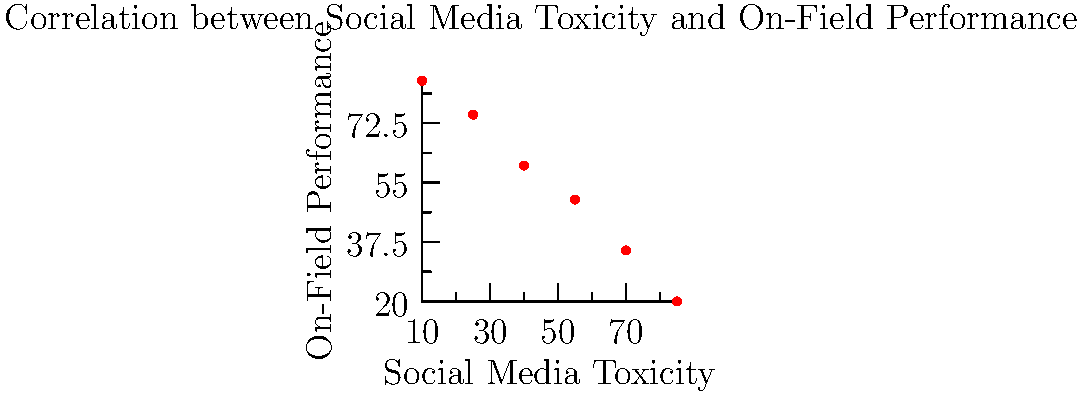Based on the scatter plot showing the relationship between social media toxicity and on-field performance for a soccer team, what type of correlation is observed, and how might this impact team morale? To answer this question, we need to analyze the scatter plot:

1. Observe the trend: As we move from left to right (increasing social media toxicity), the data points generally move downward (decreasing on-field performance).

2. Identify the correlation type: This pattern indicates a negative or inverse correlation between social media toxicity and on-field performance.

3. Strength of correlation: The points form a relatively straight line, suggesting a strong negative correlation.

4. Interpretation: As social media toxicity increases, on-field performance tends to decrease.

5. Impact on team morale:
   a) Players may feel discouraged by negative social media comments.
   b) Increased toxicity could lead to internal conflicts and reduced team cohesion.
   c) Constant criticism may affect players' confidence and mental well-being.
   d) The negative atmosphere could create a cycle of poor performance and increased toxicity.

6. Conclusion: The strong negative correlation suggests that higher levels of social media toxicity are associated with lower on-field performance, likely having a detrimental effect on team morale and overall success.
Answer: Strong negative correlation; potentially severe negative impact on team morale 